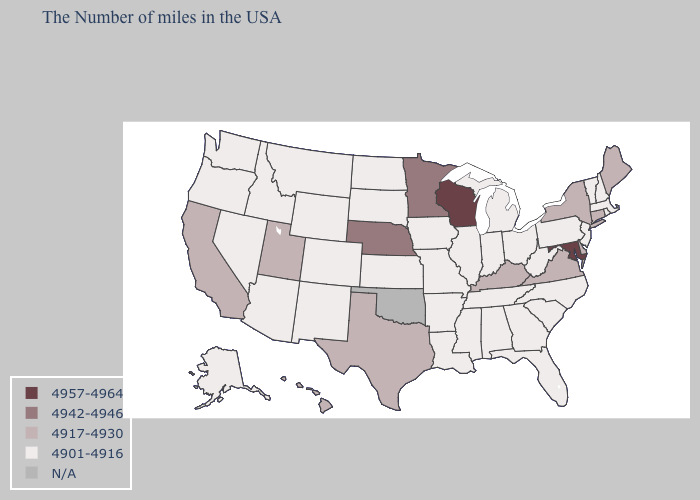What is the value of Connecticut?
Quick response, please. 4917-4930. Does Arkansas have the highest value in the USA?
Be succinct. No. Name the states that have a value in the range 4901-4916?
Be succinct. Massachusetts, Rhode Island, New Hampshire, Vermont, New Jersey, Pennsylvania, North Carolina, South Carolina, West Virginia, Ohio, Florida, Georgia, Michigan, Indiana, Alabama, Tennessee, Illinois, Mississippi, Louisiana, Missouri, Arkansas, Iowa, Kansas, South Dakota, North Dakota, Wyoming, Colorado, New Mexico, Montana, Arizona, Idaho, Nevada, Washington, Oregon, Alaska. Which states hav the highest value in the West?
Be succinct. Utah, California, Hawaii. Does the map have missing data?
Write a very short answer. Yes. Does the first symbol in the legend represent the smallest category?
Quick response, please. No. Name the states that have a value in the range 4917-4930?
Quick response, please. Maine, Connecticut, New York, Delaware, Virginia, Kentucky, Texas, Utah, California, Hawaii. What is the lowest value in states that border Ohio?
Concise answer only. 4901-4916. Name the states that have a value in the range 4917-4930?
Keep it brief. Maine, Connecticut, New York, Delaware, Virginia, Kentucky, Texas, Utah, California, Hawaii. What is the value of North Dakota?
Write a very short answer. 4901-4916. Among the states that border New Jersey , which have the highest value?
Give a very brief answer. New York, Delaware. Name the states that have a value in the range 4957-4964?
Be succinct. Maryland, Wisconsin. Name the states that have a value in the range 4942-4946?
Concise answer only. Minnesota, Nebraska. 